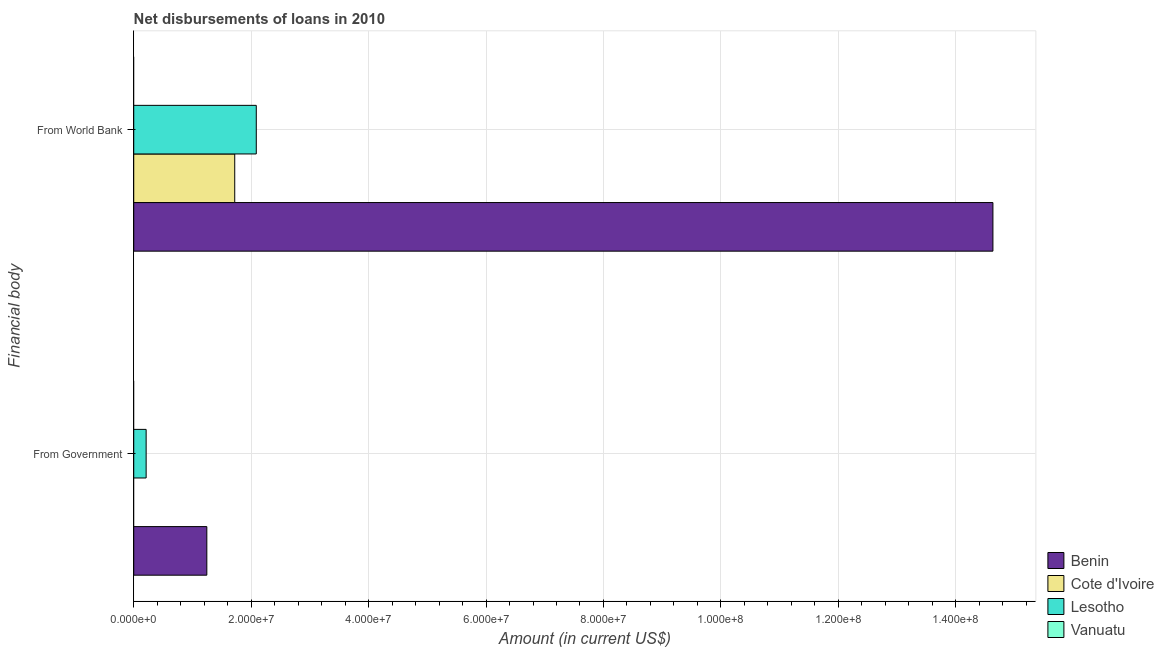How many different coloured bars are there?
Offer a terse response. 3. Are the number of bars per tick equal to the number of legend labels?
Offer a terse response. No. Are the number of bars on each tick of the Y-axis equal?
Provide a short and direct response. No. How many bars are there on the 2nd tick from the bottom?
Give a very brief answer. 3. What is the label of the 1st group of bars from the top?
Offer a very short reply. From World Bank. What is the net disbursements of loan from government in Lesotho?
Your answer should be very brief. 2.11e+06. Across all countries, what is the maximum net disbursements of loan from government?
Give a very brief answer. 1.24e+07. Across all countries, what is the minimum net disbursements of loan from world bank?
Ensure brevity in your answer.  0. In which country was the net disbursements of loan from government maximum?
Your answer should be compact. Benin. What is the total net disbursements of loan from world bank in the graph?
Ensure brevity in your answer.  1.84e+08. What is the difference between the net disbursements of loan from world bank in Benin and that in Cote d'Ivoire?
Your answer should be very brief. 1.29e+08. What is the difference between the net disbursements of loan from world bank in Lesotho and the net disbursements of loan from government in Vanuatu?
Keep it short and to the point. 2.09e+07. What is the average net disbursements of loan from world bank per country?
Your answer should be compact. 4.61e+07. What is the difference between the net disbursements of loan from government and net disbursements of loan from world bank in Lesotho?
Your response must be concise. -1.88e+07. What is the ratio of the net disbursements of loan from world bank in Lesotho to that in Cote d'Ivoire?
Give a very brief answer. 1.21. Is the net disbursements of loan from world bank in Lesotho less than that in Cote d'Ivoire?
Provide a short and direct response. No. How many bars are there?
Your answer should be very brief. 5. How many countries are there in the graph?
Your response must be concise. 4. Does the graph contain any zero values?
Offer a terse response. Yes. How many legend labels are there?
Give a very brief answer. 4. How are the legend labels stacked?
Make the answer very short. Vertical. What is the title of the graph?
Give a very brief answer. Net disbursements of loans in 2010. Does "India" appear as one of the legend labels in the graph?
Provide a short and direct response. No. What is the label or title of the Y-axis?
Keep it short and to the point. Financial body. What is the Amount (in current US$) of Benin in From Government?
Keep it short and to the point. 1.24e+07. What is the Amount (in current US$) of Cote d'Ivoire in From Government?
Provide a short and direct response. 0. What is the Amount (in current US$) in Lesotho in From Government?
Give a very brief answer. 2.11e+06. What is the Amount (in current US$) in Benin in From World Bank?
Your answer should be very brief. 1.46e+08. What is the Amount (in current US$) in Cote d'Ivoire in From World Bank?
Provide a short and direct response. 1.72e+07. What is the Amount (in current US$) in Lesotho in From World Bank?
Your response must be concise. 2.09e+07. Across all Financial body, what is the maximum Amount (in current US$) in Benin?
Offer a terse response. 1.46e+08. Across all Financial body, what is the maximum Amount (in current US$) of Cote d'Ivoire?
Provide a succinct answer. 1.72e+07. Across all Financial body, what is the maximum Amount (in current US$) of Lesotho?
Your answer should be compact. 2.09e+07. Across all Financial body, what is the minimum Amount (in current US$) in Benin?
Your answer should be very brief. 1.24e+07. Across all Financial body, what is the minimum Amount (in current US$) of Lesotho?
Provide a short and direct response. 2.11e+06. What is the total Amount (in current US$) of Benin in the graph?
Make the answer very short. 1.59e+08. What is the total Amount (in current US$) in Cote d'Ivoire in the graph?
Your answer should be very brief. 1.72e+07. What is the total Amount (in current US$) of Lesotho in the graph?
Give a very brief answer. 2.30e+07. What is the difference between the Amount (in current US$) in Benin in From Government and that in From World Bank?
Ensure brevity in your answer.  -1.34e+08. What is the difference between the Amount (in current US$) in Lesotho in From Government and that in From World Bank?
Provide a succinct answer. -1.88e+07. What is the difference between the Amount (in current US$) of Benin in From Government and the Amount (in current US$) of Cote d'Ivoire in From World Bank?
Your answer should be compact. -4.75e+06. What is the difference between the Amount (in current US$) of Benin in From Government and the Amount (in current US$) of Lesotho in From World Bank?
Ensure brevity in your answer.  -8.42e+06. What is the average Amount (in current US$) in Benin per Financial body?
Give a very brief answer. 7.94e+07. What is the average Amount (in current US$) in Cote d'Ivoire per Financial body?
Provide a succinct answer. 8.60e+06. What is the average Amount (in current US$) in Lesotho per Financial body?
Your answer should be compact. 1.15e+07. What is the average Amount (in current US$) in Vanuatu per Financial body?
Give a very brief answer. 0. What is the difference between the Amount (in current US$) of Benin and Amount (in current US$) of Lesotho in From Government?
Offer a terse response. 1.03e+07. What is the difference between the Amount (in current US$) of Benin and Amount (in current US$) of Cote d'Ivoire in From World Bank?
Ensure brevity in your answer.  1.29e+08. What is the difference between the Amount (in current US$) of Benin and Amount (in current US$) of Lesotho in From World Bank?
Provide a short and direct response. 1.25e+08. What is the difference between the Amount (in current US$) in Cote d'Ivoire and Amount (in current US$) in Lesotho in From World Bank?
Your answer should be very brief. -3.67e+06. What is the ratio of the Amount (in current US$) in Benin in From Government to that in From World Bank?
Offer a very short reply. 0.09. What is the ratio of the Amount (in current US$) of Lesotho in From Government to that in From World Bank?
Your answer should be very brief. 0.1. What is the difference between the highest and the second highest Amount (in current US$) in Benin?
Provide a short and direct response. 1.34e+08. What is the difference between the highest and the second highest Amount (in current US$) of Lesotho?
Provide a short and direct response. 1.88e+07. What is the difference between the highest and the lowest Amount (in current US$) in Benin?
Ensure brevity in your answer.  1.34e+08. What is the difference between the highest and the lowest Amount (in current US$) of Cote d'Ivoire?
Offer a terse response. 1.72e+07. What is the difference between the highest and the lowest Amount (in current US$) of Lesotho?
Your answer should be very brief. 1.88e+07. 